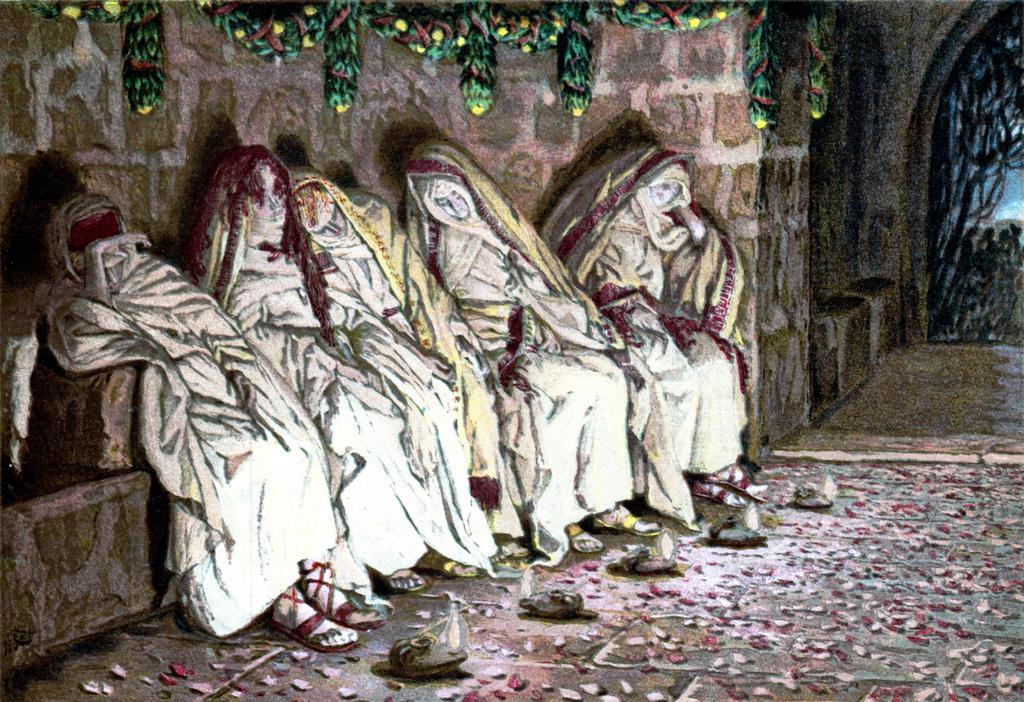How would you summarize this image in a sentence or two? This image looks like a painting. There are so many statues. There are lights at the bottom. 